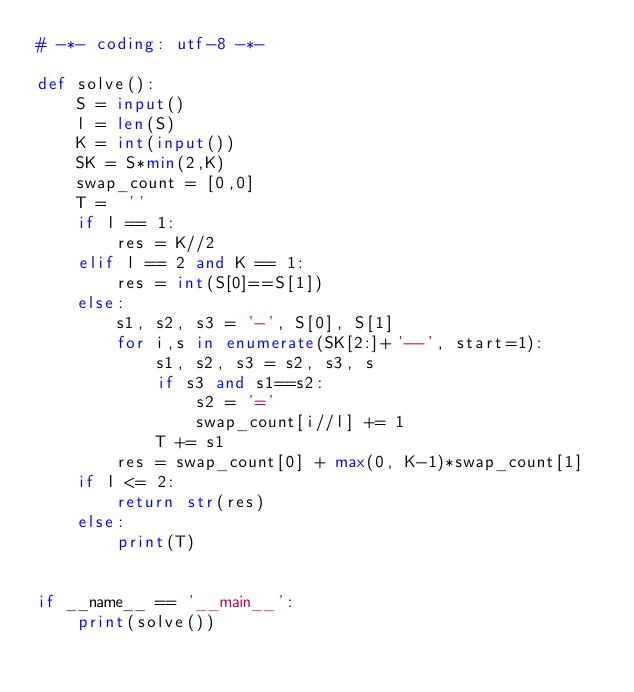Convert code to text. <code><loc_0><loc_0><loc_500><loc_500><_Python_># -*- coding: utf-8 -*-

def solve():
    S = input()
    l = len(S)
    K = int(input())
    SK = S*min(2,K)
    swap_count = [0,0]
    T =  ''
    if l == 1:
        res = K//2
    elif l == 2 and K == 1:
        res = int(S[0]==S[1])
    else:
        s1, s2, s3 = '-', S[0], S[1]
        for i,s in enumerate(SK[2:]+'--', start=1):
            s1, s2, s3 = s2, s3, s
            if s3 and s1==s2:
                s2 = '='
                swap_count[i//l] += 1
            T += s1
        res = swap_count[0] + max(0, K-1)*swap_count[1]
    if l <= 2:
        return str(res)
    else:
        print(T)
    

if __name__ == '__main__':
    print(solve())
</code> 